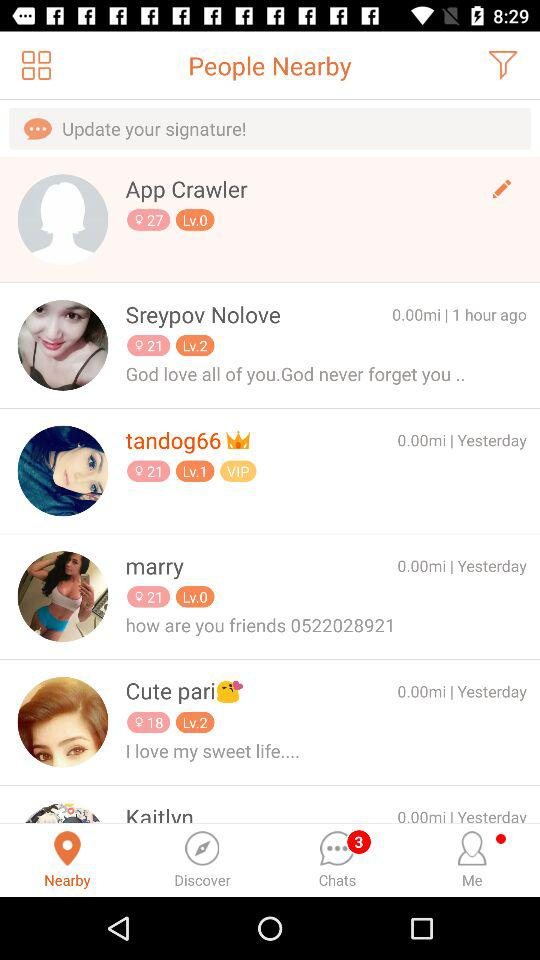What is the number of unread chats? The number of unread chats is 3. 